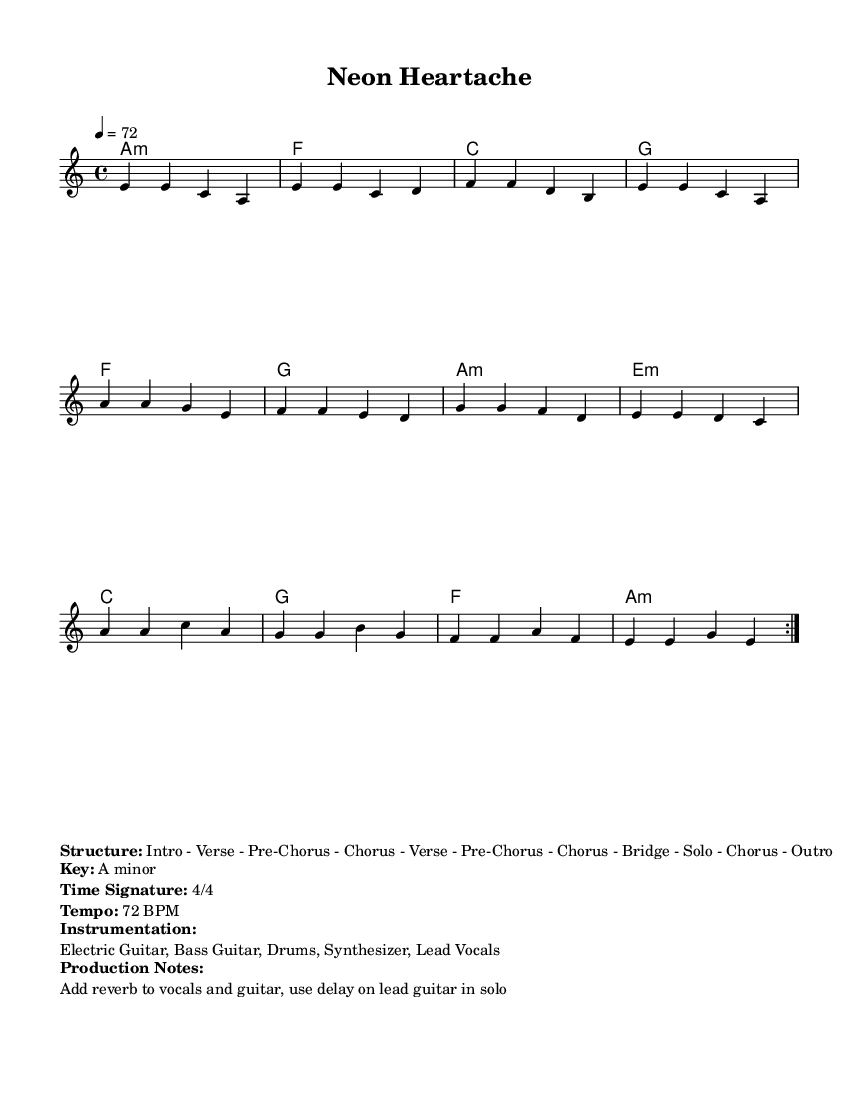What is the key signature of this music? The key signature is A minor, which has no sharps or flats. A minor is the relative minor of C major, meaning it uses the same notes.
Answer: A minor What is the time signature of this music? The time signature is 4/4, which indicates that there are four beats in each measure and a quarter note gets one beat. This is a common time signature in many genres, including blues and rock.
Answer: 4/4 What is the tempo of this music? The tempo is 72 BPM, which denotes that the music should be played at a speed of 72 beats per minute. This tempo provides a moderate pace suitable for a rock ballad.
Answer: 72 BPM What is the structure of the piece? The structure listed is Intro - Verse - Pre-Chorus - Chorus - Verse - Pre-Chorus - Chorus - Bridge - Solo - Chorus - Outro, indicating the flow of the song and how each section is arranged. Understanding the structure is essential for musicians performing the piece.
Answer: Intro - Verse - Pre-Chorus - Chorus - Verse - Pre-Chorus - Chorus - Bridge - Solo - Chorus - Outro Which instruments are indicated in the music? The instrumentation includes Electric Guitar, Bass Guitar, Drums, Synthesizer, and Lead Vocals, suggesting a full band setup typical in electric blues and rock ballads. Each instrument plays a key role in creating the overall sound.
Answer: Electric Guitar, Bass Guitar, Drums, Synthesizer, Lead Vocals How many times is the first section repeated? The first section is repeated 2 times, as indicated by the repeat symbol in the melody line. This repetition is common in popular music to reinforce catchy themes and melodies.
Answer: 2 times What production notes are mentioned for the music? The production notes suggest adding reverb to vocals and guitar and using delay on the lead guitar during the solo. These effects enhance the electric blues sound and create a more atmospheric quality in the music.
Answer: Reverb and delay 